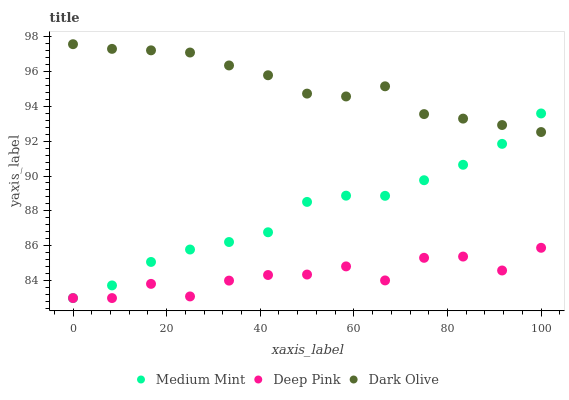Does Deep Pink have the minimum area under the curve?
Answer yes or no. Yes. Does Dark Olive have the maximum area under the curve?
Answer yes or no. Yes. Does Dark Olive have the minimum area under the curve?
Answer yes or no. No. Does Deep Pink have the maximum area under the curve?
Answer yes or no. No. Is Medium Mint the smoothest?
Answer yes or no. Yes. Is Deep Pink the roughest?
Answer yes or no. Yes. Is Dark Olive the smoothest?
Answer yes or no. No. Is Dark Olive the roughest?
Answer yes or no. No. Does Medium Mint have the lowest value?
Answer yes or no. Yes. Does Dark Olive have the lowest value?
Answer yes or no. No. Does Dark Olive have the highest value?
Answer yes or no. Yes. Does Deep Pink have the highest value?
Answer yes or no. No. Is Deep Pink less than Dark Olive?
Answer yes or no. Yes. Is Dark Olive greater than Deep Pink?
Answer yes or no. Yes. Does Medium Mint intersect Deep Pink?
Answer yes or no. Yes. Is Medium Mint less than Deep Pink?
Answer yes or no. No. Is Medium Mint greater than Deep Pink?
Answer yes or no. No. Does Deep Pink intersect Dark Olive?
Answer yes or no. No. 